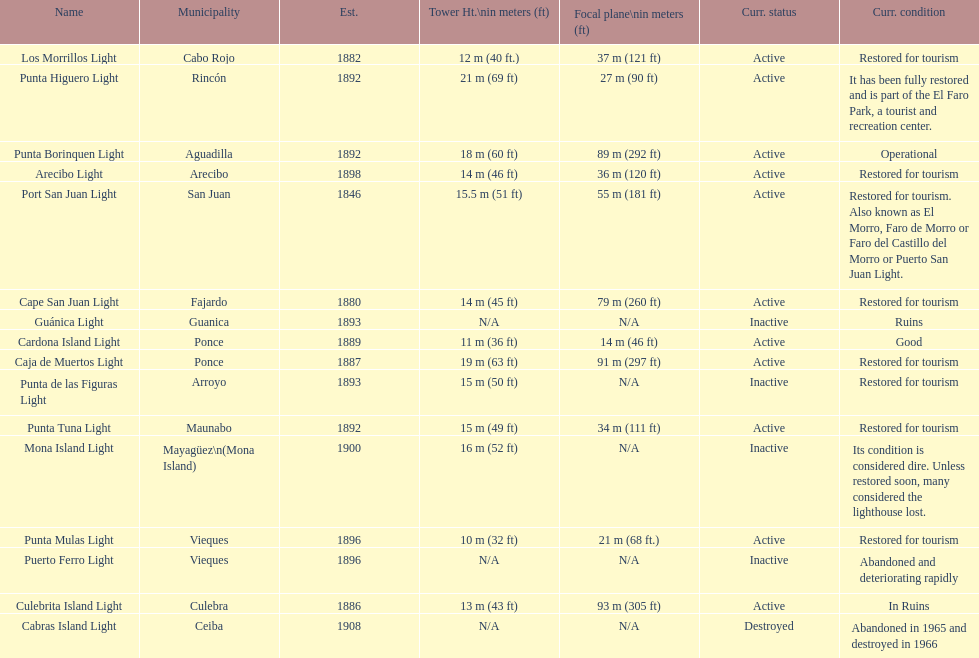Which municipality was the first to be established? San Juan. 